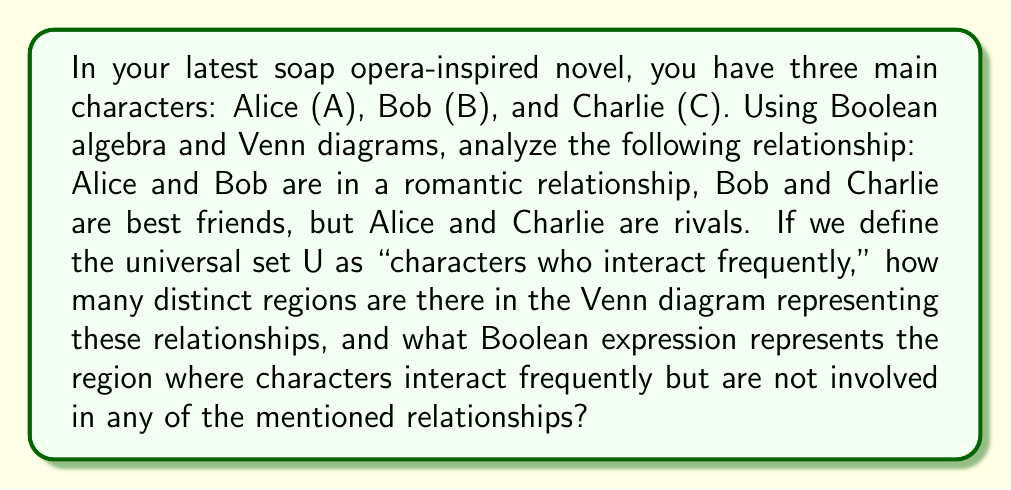Could you help me with this problem? Let's approach this step-by-step:

1) First, let's define our sets:
   A: Characters who interact with Alice
   B: Characters who interact with Bob
   C: Characters who interact with Charlie

2) Now, let's identify the relationships:
   A ∩ B: Alice and Bob's romantic relationship
   B ∩ C: Bob and Charlie's friendship
   A ∩ C: Alice and Charlie's rivalry (also an interaction)

3) To visualize this, we can draw a Venn diagram with three intersecting circles:

[asy]
unitsize(1cm);

pair A = (0,0), B = (1.5,0), C = (0.75,1.3);
real r = 1.2;

fill(circle(A,r), rgb(0.9,0.9,1));
fill(circle(B,r), rgb(0.9,1,0.9));
fill(circle(C,r), rgb(1,0.9,0.9));

draw(circle(A,r));
draw(circle(B,r));
draw(circle(C,r));

label("A", A, SW);
label("B", B, SE);
label("C", C, N);
[/asy]

4) In this Venn diagram, we can count the distinct regions:
   - 3 regions where only one set is present (A, B, C)
   - 3 regions where two sets intersect (A∩B, B∩C, A∩C)
   - 1 region where all three sets intersect (A∩B∩C)
   - 1 region outside all sets

   Total: 8 distinct regions

5) The Boolean expression for characters who interact frequently but are not involved in any of the mentioned relationships would be:

   $$ U - (A \cup B \cup C) $$

   This represents the universal set minus the union of all character interactions.

6) In Boolean algebra, this can also be written as:

   $$ \overline{A} \cdot \overline{B} \cdot \overline{C} $$

   Where $\overline{X}$ represents the complement of X, and · represents AND.
Answer: 8 distinct regions; $\overline{A} \cdot \overline{B} \cdot \overline{C}$ 